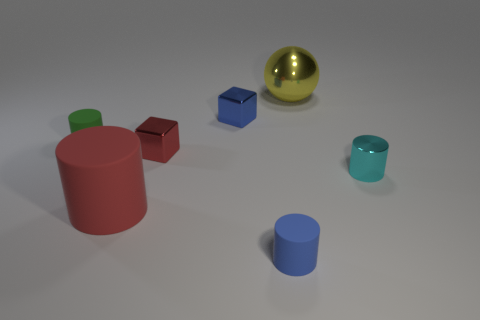Subtract all blue cylinders. How many cylinders are left? 3 Subtract all small cyan cylinders. How many cylinders are left? 3 Subtract 0 gray spheres. How many objects are left? 7 Subtract all blocks. How many objects are left? 5 Subtract 2 cubes. How many cubes are left? 0 Subtract all blue balls. Subtract all red blocks. How many balls are left? 1 Subtract all cyan cylinders. How many red spheres are left? 0 Subtract all tiny cyan shiny cylinders. Subtract all large balls. How many objects are left? 5 Add 1 red cylinders. How many red cylinders are left? 2 Add 3 cyan matte spheres. How many cyan matte spheres exist? 3 